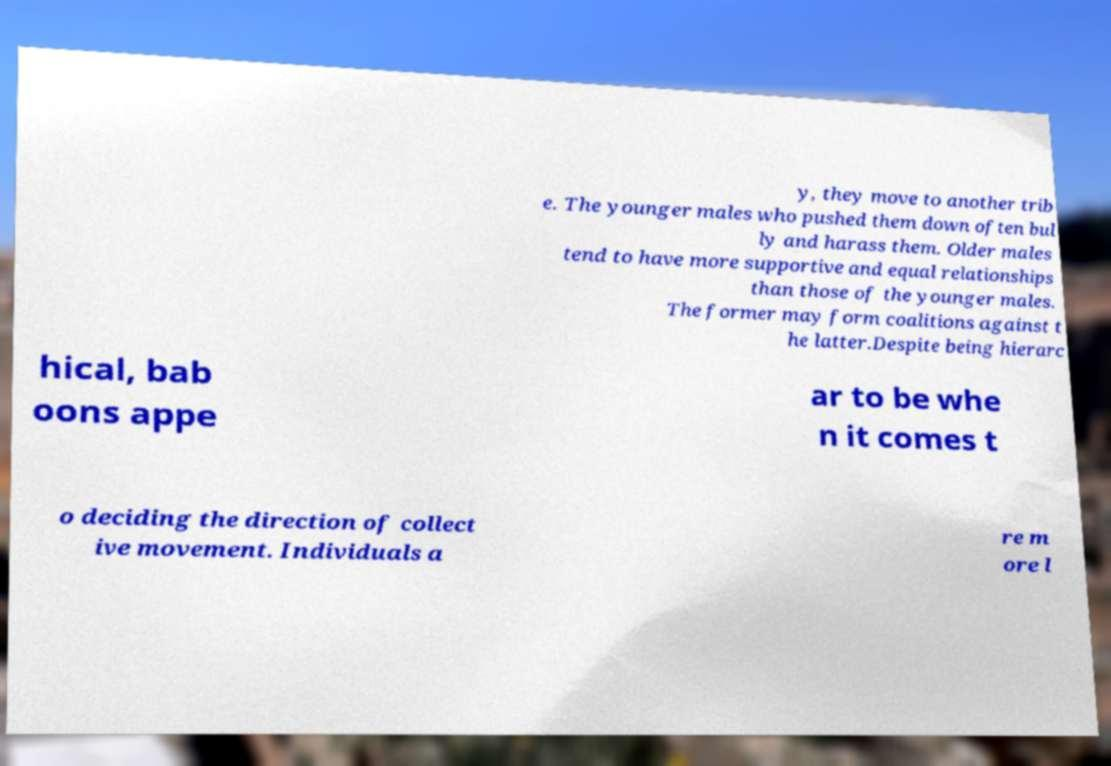Please identify and transcribe the text found in this image. y, they move to another trib e. The younger males who pushed them down often bul ly and harass them. Older males tend to have more supportive and equal relationships than those of the younger males. The former may form coalitions against t he latter.Despite being hierarc hical, bab oons appe ar to be whe n it comes t o deciding the direction of collect ive movement. Individuals a re m ore l 